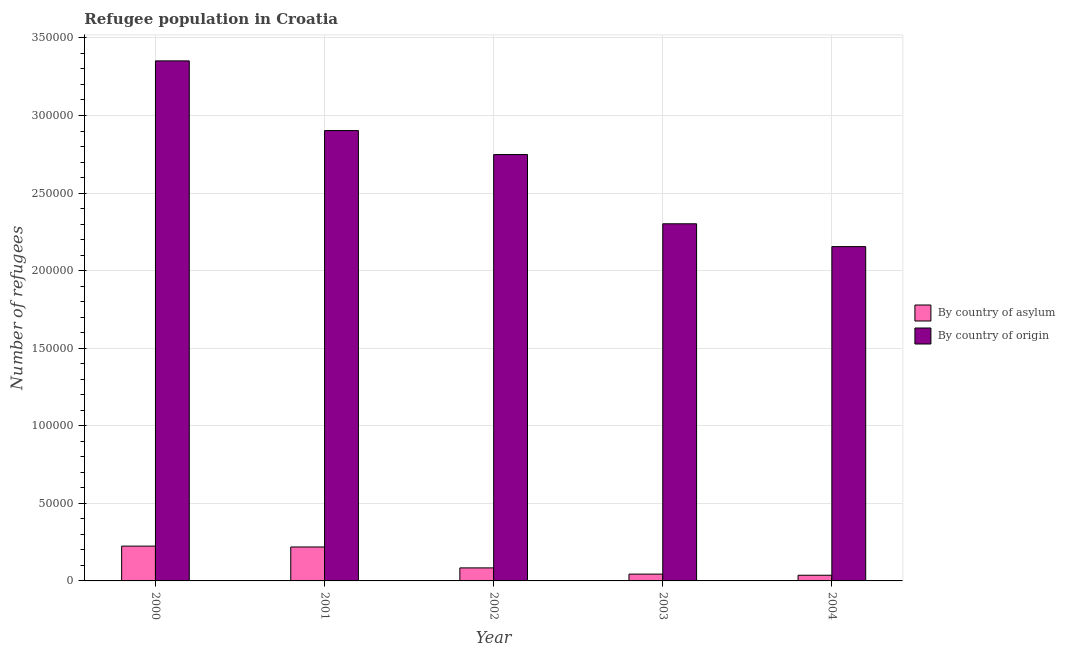How many different coloured bars are there?
Keep it short and to the point. 2. How many groups of bars are there?
Your answer should be very brief. 5. Are the number of bars per tick equal to the number of legend labels?
Offer a very short reply. Yes. Are the number of bars on each tick of the X-axis equal?
Offer a terse response. Yes. How many bars are there on the 5th tick from the right?
Make the answer very short. 2. In how many cases, is the number of bars for a given year not equal to the number of legend labels?
Your answer should be very brief. 0. What is the number of refugees by country of asylum in 2000?
Ensure brevity in your answer.  2.24e+04. Across all years, what is the maximum number of refugees by country of origin?
Provide a short and direct response. 3.35e+05. Across all years, what is the minimum number of refugees by country of origin?
Your answer should be very brief. 2.15e+05. In which year was the number of refugees by country of origin maximum?
Make the answer very short. 2000. What is the total number of refugees by country of origin in the graph?
Offer a very short reply. 1.35e+06. What is the difference between the number of refugees by country of asylum in 2000 and that in 2002?
Make the answer very short. 1.40e+04. What is the difference between the number of refugees by country of asylum in 2004 and the number of refugees by country of origin in 2002?
Your answer should be very brief. -4729. What is the average number of refugees by country of origin per year?
Provide a short and direct response. 2.69e+05. In how many years, is the number of refugees by country of origin greater than 220000?
Offer a terse response. 4. What is the ratio of the number of refugees by country of asylum in 2000 to that in 2001?
Offer a very short reply. 1.03. Is the difference between the number of refugees by country of asylum in 2000 and 2004 greater than the difference between the number of refugees by country of origin in 2000 and 2004?
Ensure brevity in your answer.  No. What is the difference between the highest and the second highest number of refugees by country of asylum?
Keep it short and to the point. 562. What is the difference between the highest and the lowest number of refugees by country of asylum?
Offer a terse response. 1.88e+04. Is the sum of the number of refugees by country of origin in 2000 and 2003 greater than the maximum number of refugees by country of asylum across all years?
Give a very brief answer. Yes. What does the 2nd bar from the left in 2001 represents?
Make the answer very short. By country of origin. What does the 1st bar from the right in 2002 represents?
Your response must be concise. By country of origin. How many bars are there?
Your answer should be compact. 10. Are all the bars in the graph horizontal?
Provide a short and direct response. No. How many years are there in the graph?
Make the answer very short. 5. Does the graph contain any zero values?
Provide a succinct answer. No. Does the graph contain grids?
Your answer should be very brief. Yes. What is the title of the graph?
Make the answer very short. Refugee population in Croatia. Does "Broad money growth" appear as one of the legend labels in the graph?
Keep it short and to the point. No. What is the label or title of the X-axis?
Keep it short and to the point. Year. What is the label or title of the Y-axis?
Keep it short and to the point. Number of refugees. What is the Number of refugees in By country of asylum in 2000?
Keep it short and to the point. 2.24e+04. What is the Number of refugees of By country of origin in 2000?
Provide a succinct answer. 3.35e+05. What is the Number of refugees of By country of asylum in 2001?
Your answer should be very brief. 2.19e+04. What is the Number of refugees of By country of origin in 2001?
Your answer should be very brief. 2.90e+05. What is the Number of refugees of By country of asylum in 2002?
Your response must be concise. 8392. What is the Number of refugees of By country of origin in 2002?
Give a very brief answer. 2.75e+05. What is the Number of refugees in By country of asylum in 2003?
Make the answer very short. 4387. What is the Number of refugees of By country of origin in 2003?
Provide a short and direct response. 2.30e+05. What is the Number of refugees of By country of asylum in 2004?
Make the answer very short. 3663. What is the Number of refugees of By country of origin in 2004?
Give a very brief answer. 2.15e+05. Across all years, what is the maximum Number of refugees of By country of asylum?
Ensure brevity in your answer.  2.24e+04. Across all years, what is the maximum Number of refugees of By country of origin?
Your answer should be very brief. 3.35e+05. Across all years, what is the minimum Number of refugees in By country of asylum?
Provide a succinct answer. 3663. Across all years, what is the minimum Number of refugees of By country of origin?
Offer a terse response. 2.15e+05. What is the total Number of refugees of By country of asylum in the graph?
Your answer should be compact. 6.08e+04. What is the total Number of refugees in By country of origin in the graph?
Keep it short and to the point. 1.35e+06. What is the difference between the Number of refugees in By country of asylum in 2000 and that in 2001?
Ensure brevity in your answer.  562. What is the difference between the Number of refugees of By country of origin in 2000 and that in 2001?
Your answer should be compact. 4.49e+04. What is the difference between the Number of refugees of By country of asylum in 2000 and that in 2002?
Your response must be concise. 1.40e+04. What is the difference between the Number of refugees in By country of origin in 2000 and that in 2002?
Your answer should be very brief. 6.04e+04. What is the difference between the Number of refugees in By country of asylum in 2000 and that in 2003?
Your answer should be compact. 1.80e+04. What is the difference between the Number of refugees in By country of origin in 2000 and that in 2003?
Provide a short and direct response. 1.05e+05. What is the difference between the Number of refugees in By country of asylum in 2000 and that in 2004?
Ensure brevity in your answer.  1.88e+04. What is the difference between the Number of refugees of By country of origin in 2000 and that in 2004?
Make the answer very short. 1.20e+05. What is the difference between the Number of refugees of By country of asylum in 2001 and that in 2002?
Keep it short and to the point. 1.35e+04. What is the difference between the Number of refugees of By country of origin in 2001 and that in 2002?
Keep it short and to the point. 1.55e+04. What is the difference between the Number of refugees in By country of asylum in 2001 and that in 2003?
Make the answer very short. 1.75e+04. What is the difference between the Number of refugees of By country of origin in 2001 and that in 2003?
Keep it short and to the point. 6.01e+04. What is the difference between the Number of refugees of By country of asylum in 2001 and that in 2004?
Your response must be concise. 1.82e+04. What is the difference between the Number of refugees of By country of origin in 2001 and that in 2004?
Ensure brevity in your answer.  7.48e+04. What is the difference between the Number of refugees of By country of asylum in 2002 and that in 2003?
Your answer should be very brief. 4005. What is the difference between the Number of refugees in By country of origin in 2002 and that in 2003?
Your answer should be very brief. 4.46e+04. What is the difference between the Number of refugees of By country of asylum in 2002 and that in 2004?
Give a very brief answer. 4729. What is the difference between the Number of refugees in By country of origin in 2002 and that in 2004?
Your answer should be very brief. 5.93e+04. What is the difference between the Number of refugees in By country of asylum in 2003 and that in 2004?
Keep it short and to the point. 724. What is the difference between the Number of refugees of By country of origin in 2003 and that in 2004?
Provide a short and direct response. 1.47e+04. What is the difference between the Number of refugees in By country of asylum in 2000 and the Number of refugees in By country of origin in 2001?
Offer a terse response. -2.68e+05. What is the difference between the Number of refugees of By country of asylum in 2000 and the Number of refugees of By country of origin in 2002?
Offer a very short reply. -2.52e+05. What is the difference between the Number of refugees of By country of asylum in 2000 and the Number of refugees of By country of origin in 2003?
Offer a terse response. -2.08e+05. What is the difference between the Number of refugees in By country of asylum in 2000 and the Number of refugees in By country of origin in 2004?
Provide a short and direct response. -1.93e+05. What is the difference between the Number of refugees in By country of asylum in 2001 and the Number of refugees in By country of origin in 2002?
Your answer should be very brief. -2.53e+05. What is the difference between the Number of refugees of By country of asylum in 2001 and the Number of refugees of By country of origin in 2003?
Provide a short and direct response. -2.08e+05. What is the difference between the Number of refugees in By country of asylum in 2001 and the Number of refugees in By country of origin in 2004?
Provide a short and direct response. -1.94e+05. What is the difference between the Number of refugees in By country of asylum in 2002 and the Number of refugees in By country of origin in 2003?
Offer a very short reply. -2.22e+05. What is the difference between the Number of refugees of By country of asylum in 2002 and the Number of refugees of By country of origin in 2004?
Offer a very short reply. -2.07e+05. What is the difference between the Number of refugees in By country of asylum in 2003 and the Number of refugees in By country of origin in 2004?
Ensure brevity in your answer.  -2.11e+05. What is the average Number of refugees in By country of asylum per year?
Offer a very short reply. 1.22e+04. What is the average Number of refugees of By country of origin per year?
Your answer should be compact. 2.69e+05. In the year 2000, what is the difference between the Number of refugees of By country of asylum and Number of refugees of By country of origin?
Your response must be concise. -3.13e+05. In the year 2001, what is the difference between the Number of refugees in By country of asylum and Number of refugees in By country of origin?
Keep it short and to the point. -2.68e+05. In the year 2002, what is the difference between the Number of refugees in By country of asylum and Number of refugees in By country of origin?
Offer a terse response. -2.66e+05. In the year 2003, what is the difference between the Number of refugees of By country of asylum and Number of refugees of By country of origin?
Your response must be concise. -2.26e+05. In the year 2004, what is the difference between the Number of refugees of By country of asylum and Number of refugees of By country of origin?
Ensure brevity in your answer.  -2.12e+05. What is the ratio of the Number of refugees in By country of asylum in 2000 to that in 2001?
Your answer should be compact. 1.03. What is the ratio of the Number of refugees in By country of origin in 2000 to that in 2001?
Make the answer very short. 1.15. What is the ratio of the Number of refugees of By country of asylum in 2000 to that in 2002?
Your answer should be very brief. 2.67. What is the ratio of the Number of refugees in By country of origin in 2000 to that in 2002?
Provide a succinct answer. 1.22. What is the ratio of the Number of refugees in By country of asylum in 2000 to that in 2003?
Offer a terse response. 5.11. What is the ratio of the Number of refugees of By country of origin in 2000 to that in 2003?
Offer a very short reply. 1.46. What is the ratio of the Number of refugees in By country of asylum in 2000 to that in 2004?
Offer a terse response. 6.13. What is the ratio of the Number of refugees in By country of origin in 2000 to that in 2004?
Make the answer very short. 1.56. What is the ratio of the Number of refugees of By country of asylum in 2001 to that in 2002?
Give a very brief answer. 2.61. What is the ratio of the Number of refugees in By country of origin in 2001 to that in 2002?
Your answer should be compact. 1.06. What is the ratio of the Number of refugees in By country of asylum in 2001 to that in 2003?
Keep it short and to the point. 4.99. What is the ratio of the Number of refugees of By country of origin in 2001 to that in 2003?
Give a very brief answer. 1.26. What is the ratio of the Number of refugees in By country of asylum in 2001 to that in 2004?
Your answer should be very brief. 5.97. What is the ratio of the Number of refugees in By country of origin in 2001 to that in 2004?
Give a very brief answer. 1.35. What is the ratio of the Number of refugees of By country of asylum in 2002 to that in 2003?
Ensure brevity in your answer.  1.91. What is the ratio of the Number of refugees in By country of origin in 2002 to that in 2003?
Your answer should be very brief. 1.19. What is the ratio of the Number of refugees of By country of asylum in 2002 to that in 2004?
Ensure brevity in your answer.  2.29. What is the ratio of the Number of refugees in By country of origin in 2002 to that in 2004?
Offer a very short reply. 1.28. What is the ratio of the Number of refugees of By country of asylum in 2003 to that in 2004?
Ensure brevity in your answer.  1.2. What is the ratio of the Number of refugees in By country of origin in 2003 to that in 2004?
Your answer should be compact. 1.07. What is the difference between the highest and the second highest Number of refugees in By country of asylum?
Keep it short and to the point. 562. What is the difference between the highest and the second highest Number of refugees in By country of origin?
Offer a terse response. 4.49e+04. What is the difference between the highest and the lowest Number of refugees in By country of asylum?
Offer a very short reply. 1.88e+04. What is the difference between the highest and the lowest Number of refugees in By country of origin?
Keep it short and to the point. 1.20e+05. 